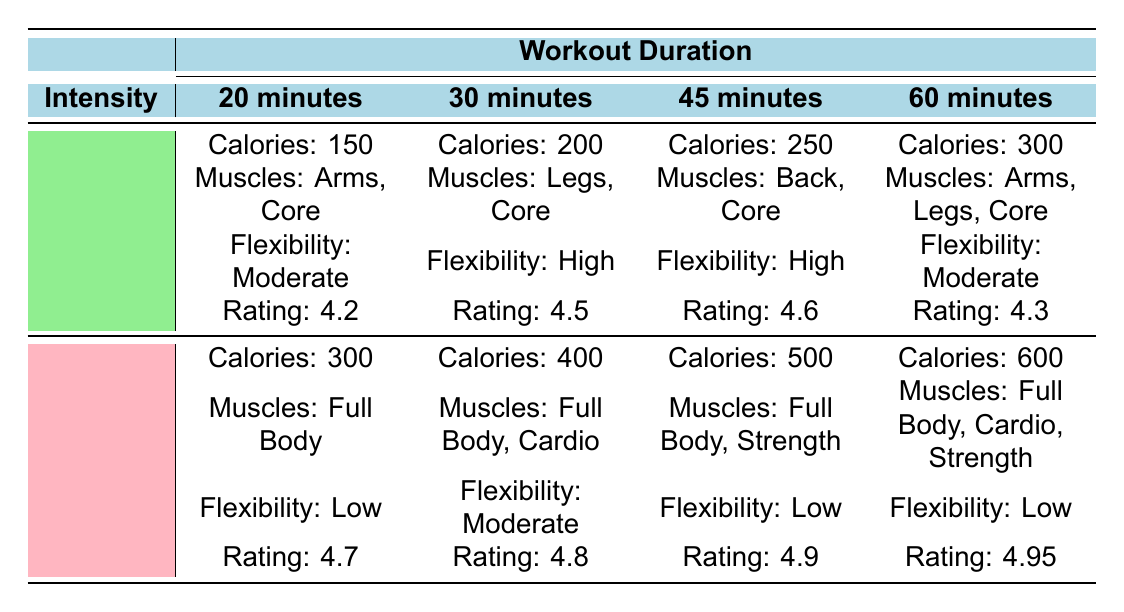What is the average user rating for the 30-minute high-intensity workout? The table shows that the average user rating for the 30-minute high-intensity workout is listed as 4.8. This is directly found in the high-intensity row under the 30-minute column.
Answer: 4.8 How many muscle groups are targeted in the 60-minute low-intensity workout? The table indicates that the 60-minute low-intensity workout targets three muscle groups: Arms, Legs, and Core. This information is found in the relevant section of the table.
Answer: 3 What is the difference in calories burned between the 20-minute high-intensity and the 20-minute low-intensity workouts? The 20-minute high-intensity workout burns 300 calories, and the 20-minute low-intensity workout burns 150 calories. The difference is calculated as 300 - 150 = 150 calories.
Answer: 150 Is the improvement in flexibility higher for the 30-minute low-intensity workout compared to the 45-minute low-intensity workout? The table shows that the improvement in flexibility for the 30-minute low-intensity workout is High, while it is also High for the 45-minute low-intensity workout. Since they are the same, the answer is no.
Answer: No Which workout duration has the highest average user rating, and what is that rating? The table reveals that the 60-minute high-intensity workout has the highest average user rating at 4.95. This is found by comparing the average ratings across all durations and intensities.
Answer: 60 minutes, 4.95 How many calories do you burn if you do a 45-minute workout at high intensity? According to the table, a 45-minute high-intensity workout burns 500 calories, which is specified in the respective section.
Answer: 500 Which workout duration burns the most calories, and what are the muscle groups targeted? The 60-minute high-intensity workout burns the most calories at 600. It targets the muscle groups Full Body, Cardio, and Strength, as found in the high-intensity row under the 60-minute column.
Answer: 600 calories, Full Body, Cardio, Strength Does the low-intensity workout for 20 minutes improve flexibility more than the 30-minute high-intensity workout? The low-intensity workout for 20 minutes has a moderate improvement in flexibility, whereas the 30-minute high-intensity workout has a low improvement. Thus, yes, the 20-minute low-intensity workout does improve flexibility more.
Answer: Yes What is the total calories burned in a low-intensity workout across all durations listed? From the table, the calories burned for low-intensity workouts are: 150 for 20 minutes, 200 for 30 minutes, 250 for 45 minutes, and 300 for 60 minutes. Adding these gives 150 + 200 + 250 + 300 = 900 calories burned in total.
Answer: 900 